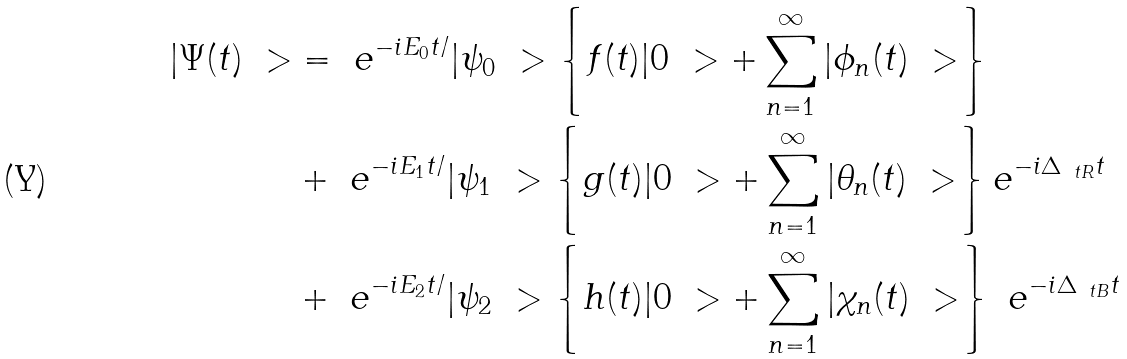Convert formula to latex. <formula><loc_0><loc_0><loc_500><loc_500>| \Psi ( t ) \ > & = \ e ^ { - i E _ { 0 } t / } | \psi _ { 0 } \ > \left \{ f ( t ) | 0 \ > + \sum _ { n = 1 } ^ { \infty } | \phi _ { n } ( t ) \ > \right \} \\ & + \ e ^ { - i E _ { 1 } t / } | \psi _ { 1 } \ > \left \{ g ( t ) | 0 \ > + \sum _ { n = 1 } ^ { \infty } | \theta _ { n } ( t ) \ > \right \} e ^ { - i \Delta _ { \ t R } t } \\ & + \ e ^ { - i E _ { 2 } t / } | \psi _ { 2 } \ > \left \{ h ( t ) | 0 \ > + \sum _ { n = 1 } ^ { \infty } | \chi _ { n } ( t ) \ > \right \} \ e ^ { - i \Delta _ { \ t B } t }</formula> 